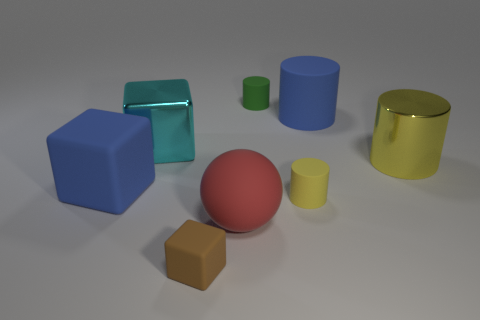Can you describe the texture and material of the objects present in the image? The objects in the image appear to have different textures and materials. The blue and green cylinders have a glossy finish indicative of a smooth, possibly metallic or plastic surface. The brown cube looks matte, suggesting a more rough texture akin to wood or cardboard. The red sphere and the yellow cylinder share a similar sheen to the blue and green cylinders, implying a reflective material. 